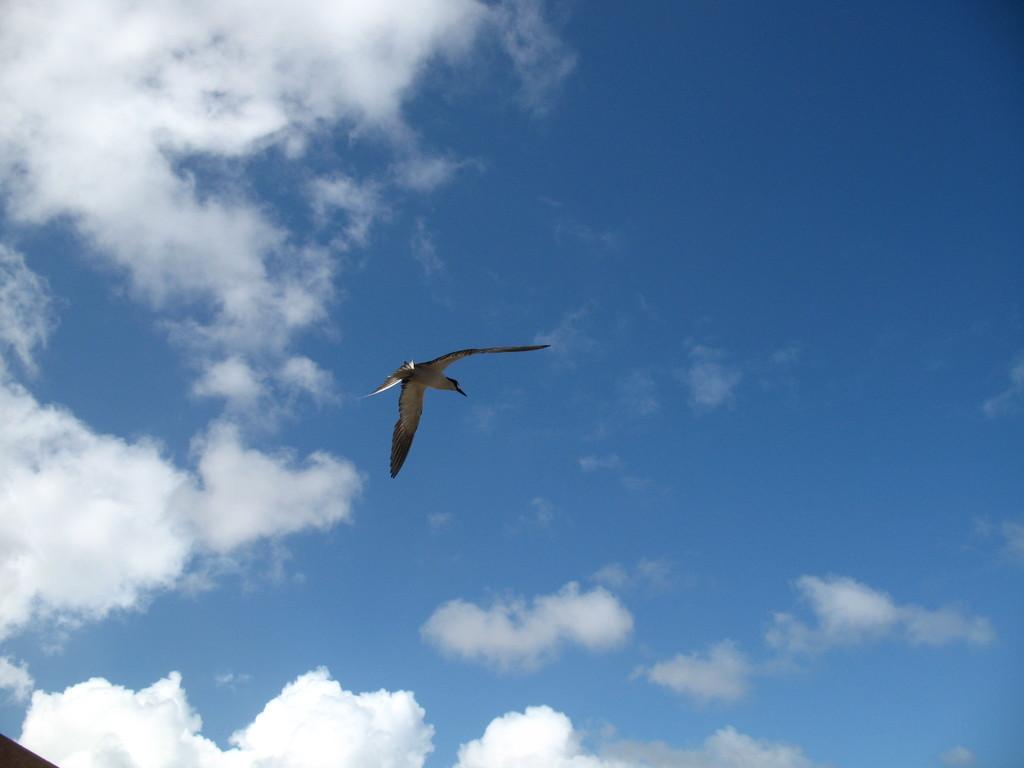Describe this image in one or two sentences. In this image I can see a bird flying in the air. In the background I can see the clouds and the blue sky. 